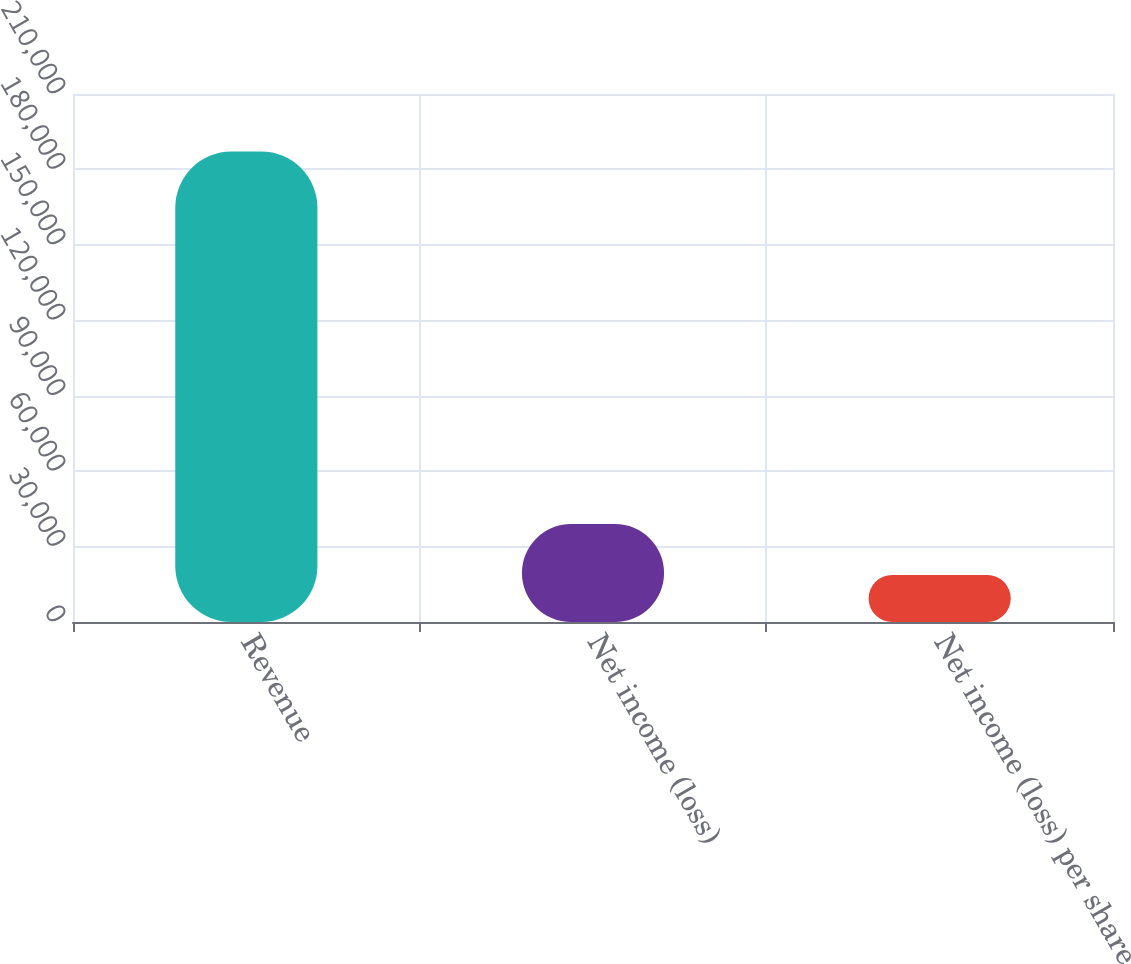<chart> <loc_0><loc_0><loc_500><loc_500><bar_chart><fcel>Revenue<fcel>Net income (loss)<fcel>Net income (loss) per share<nl><fcel>187103<fcel>38957<fcel>18710.9<nl></chart> 